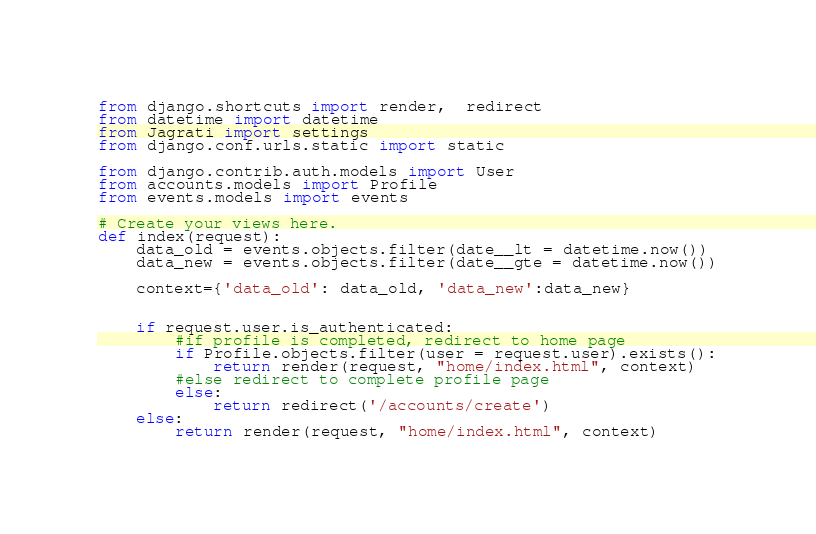<code> <loc_0><loc_0><loc_500><loc_500><_Python_>from django.shortcuts import render,  redirect
from datetime import datetime
from Jagrati import settings
from django.conf.urls.static import static 

from django.contrib.auth.models import User
from accounts.models import Profile
from events.models import events

# Create your views here.
def index(request):
	data_old = events.objects.filter(date__lt = datetime.now())
	data_new = events.objects.filter(date__gte = datetime.now())
	
	context={'data_old': data_old, 'data_new':data_new}

	
	if request.user.is_authenticated:
		#if profile is completed, redirect to home page
		if Profile.objects.filter(user = request.user).exists():
			return render(request, "home/index.html", context)
		#else redirect to complete profile page
		else:
			return redirect('/accounts/create')
	else:
		return render(request, "home/index.html", context)
</code> 